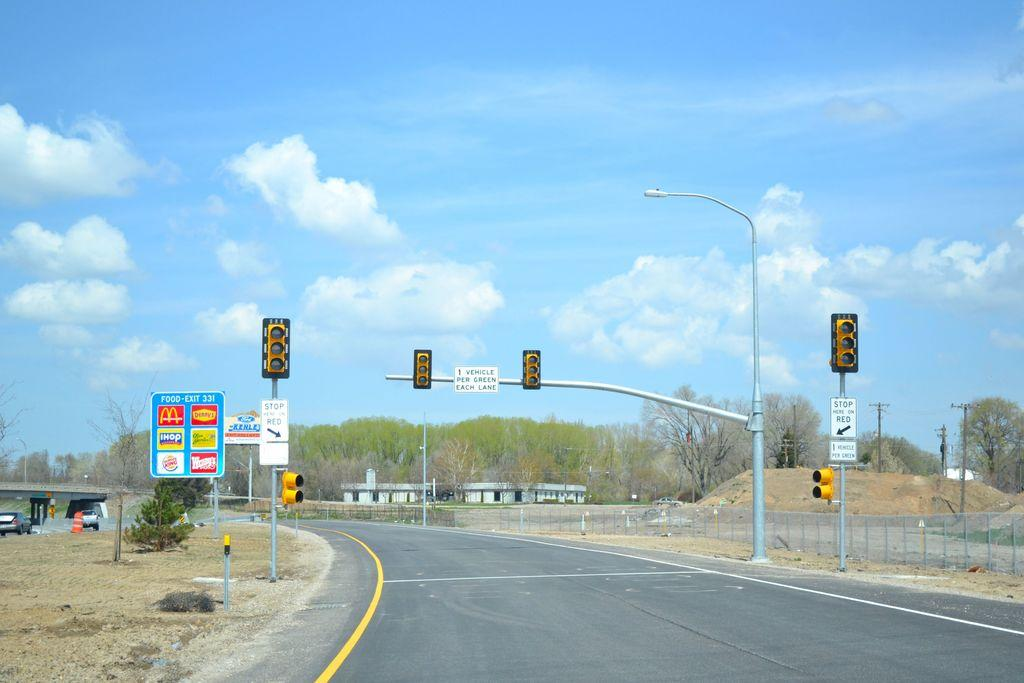<image>
Create a compact narrative representing the image presented. A road with a sign for McDonald's on the left. 